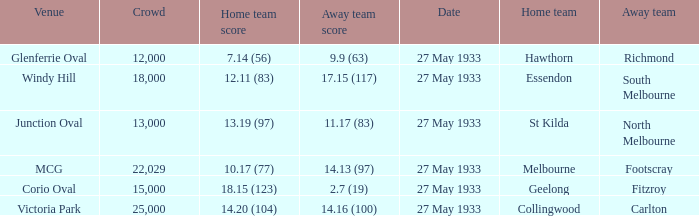In the match where the away team scored 2.7 (19), how many peopel were in the crowd? 15000.0. 